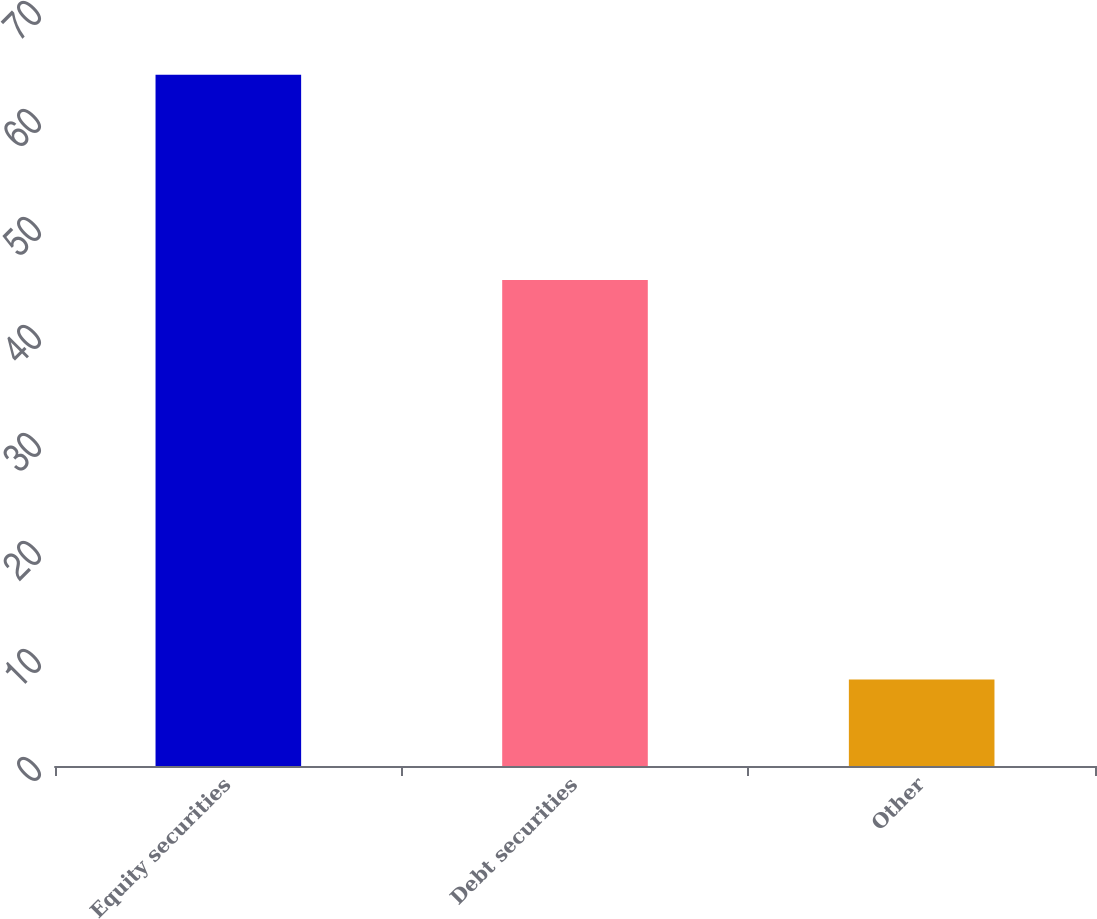<chart> <loc_0><loc_0><loc_500><loc_500><bar_chart><fcel>Equity securities<fcel>Debt securities<fcel>Other<nl><fcel>64<fcel>45<fcel>8<nl></chart> 